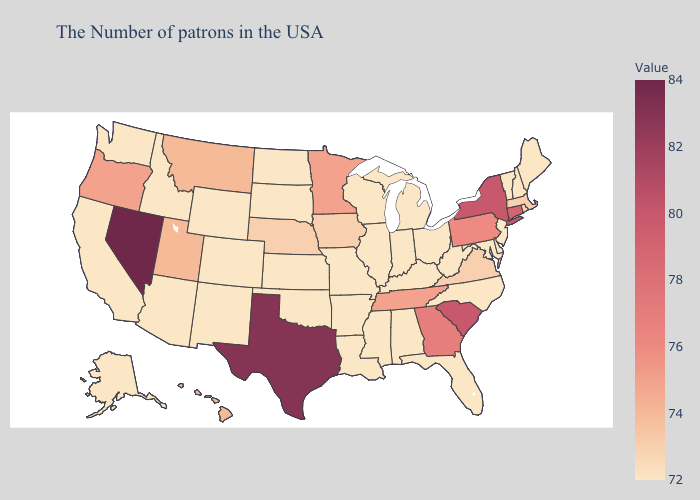Does South Carolina have a lower value than Nevada?
Write a very short answer. Yes. Which states hav the highest value in the Northeast?
Give a very brief answer. New York. Does Kansas have a higher value than Tennessee?
Keep it brief. No. Among the states that border Virginia , does Tennessee have the lowest value?
Write a very short answer. No. Does Utah have a lower value than New Jersey?
Give a very brief answer. No. 